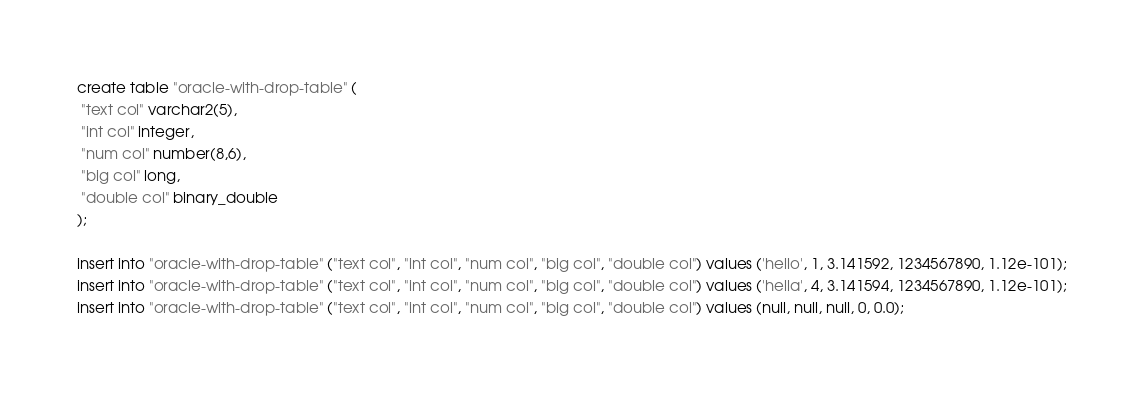Convert code to text. <code><loc_0><loc_0><loc_500><loc_500><_SQL_>
create table "oracle-with-drop-table" (
 "text col" varchar2(5),
 "int col" integer,
 "num col" number(8,6),
 "big col" long,
 "double col" binary_double
);

insert into "oracle-with-drop-table" ("text col", "int col", "num col", "big col", "double col") values ('hello', 1, 3.141592, 1234567890, 1.12e-101);
insert into "oracle-with-drop-table" ("text col", "int col", "num col", "big col", "double col") values ('hella', 4, 3.141594, 1234567890, 1.12e-101);
insert into "oracle-with-drop-table" ("text col", "int col", "num col", "big col", "double col") values (null, null, null, 0, 0.0);</code> 